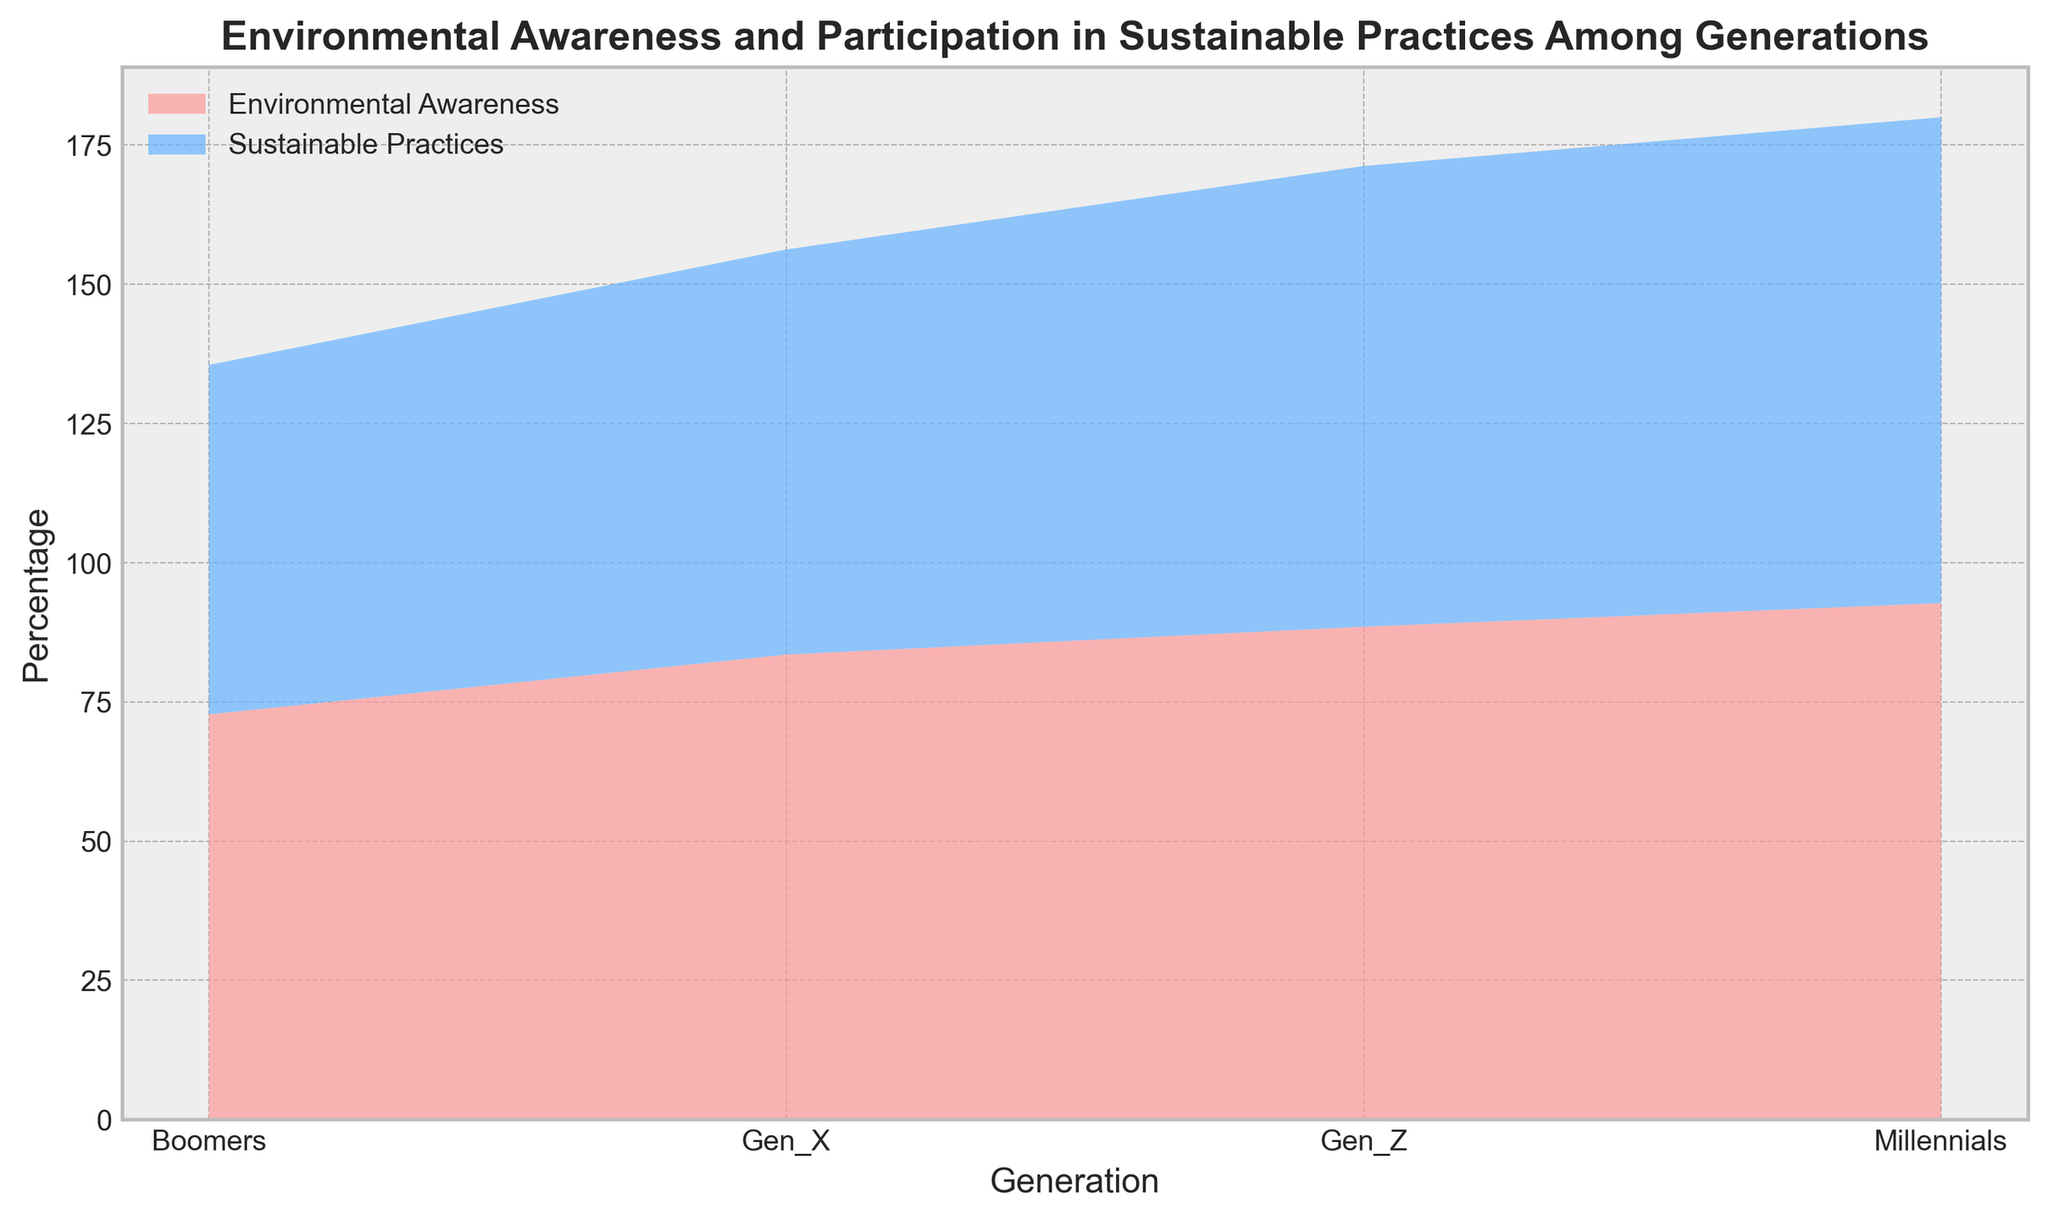Which generation has the highest participation in sustainable practices? By examining the area plot, we can see that Millennials have the tallest section in the "Participation in Sustainable Practices" area, indicating they have the highest percentage.
Answer: Millennials How much more aware are Millennials compared to Boomers, based on Environmental Awareness? Look at the peak of the "Environmental Awareness" areas for both generations. Millennial's peak is at 95%, and Boomer's peak is at 75%. The difference is calculated as 95 - 75.
Answer: 20% Which generation shows the least difference between their Environmental Awareness and Participation in Sustainable Practices? Examine each generation's difference between Environmental Awareness and Participation in Sustainable Practices. For Millennials, it's 95 - 89 = 6. For Boomers, it's 75 - 65 = 10. For Gen X, it's 86 - 75 = 11. For Gen Z, it's 91 - 85 = 6. Both Millennials and Gen Z have the smallest difference.
Answer: Millennials and Gen Z What is the average Environmental Awareness across all generations? Add the Environmental Awareness values for each generation and divide by the number of generations: (75 + 86 + 95 + 91)/4 = 86.75.
Answer: 86.75% Between Gen X and Gen Z, which generation has a higher participation in sustainable practices? Compare the height of the "Participation in Sustainable Practices" areas for Gen X and Gen Z. Gen Z has a higher value (85%) compared to Gen X (75%).
Answer: Gen Z What is the total percentage value combining both Environmental Awareness and Participation in Sustainable Practices for Boomers? Add Boomers' values for both Environmental Awareness (75%) and Participation in Sustainable Practices (65%): 75 + 65 = 140.
Answer: 140% Out of all generations, which one shows the highest combined total of Environmental Awareness and Participation in Sustainable Practices, and what is the value? Combine the values for Environmental Awareness and Participation in Sustainable Practices for each generation. Compare to find the highest: Boomers (75+65 = 140), Gen X (86+75 = 161), Millennials (95+89 = 184), Gen Z (91+85 = 176). The highest value is from Millennials with 184.
Answer: Millennials, 184 What percentage does Gen X contribute to Environmental Awareness compared to the total sum of environmental awareness across all generations? First, compute the total Environmental Awareness: 75 + 86 + 95 + 91 = 347. Then, find the contribution of Gen X: (86/347) * 100 = 24.78%.
Answer: 24.78% Which generation shows the steadier growth trend in both Environmental Awareness and Participation in Sustainable Practices? By observing the plot, Gen X shows a consistent increase in both Environmental Awareness and Participation in Sustainable Practices, indicating steady growth in both metrics.
Answer: Gen X 